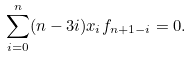Convert formula to latex. <formula><loc_0><loc_0><loc_500><loc_500>\sum _ { i = 0 } ^ { n } ( n - 3 i ) x _ { i } f _ { n + 1 - i } = 0 .</formula> 